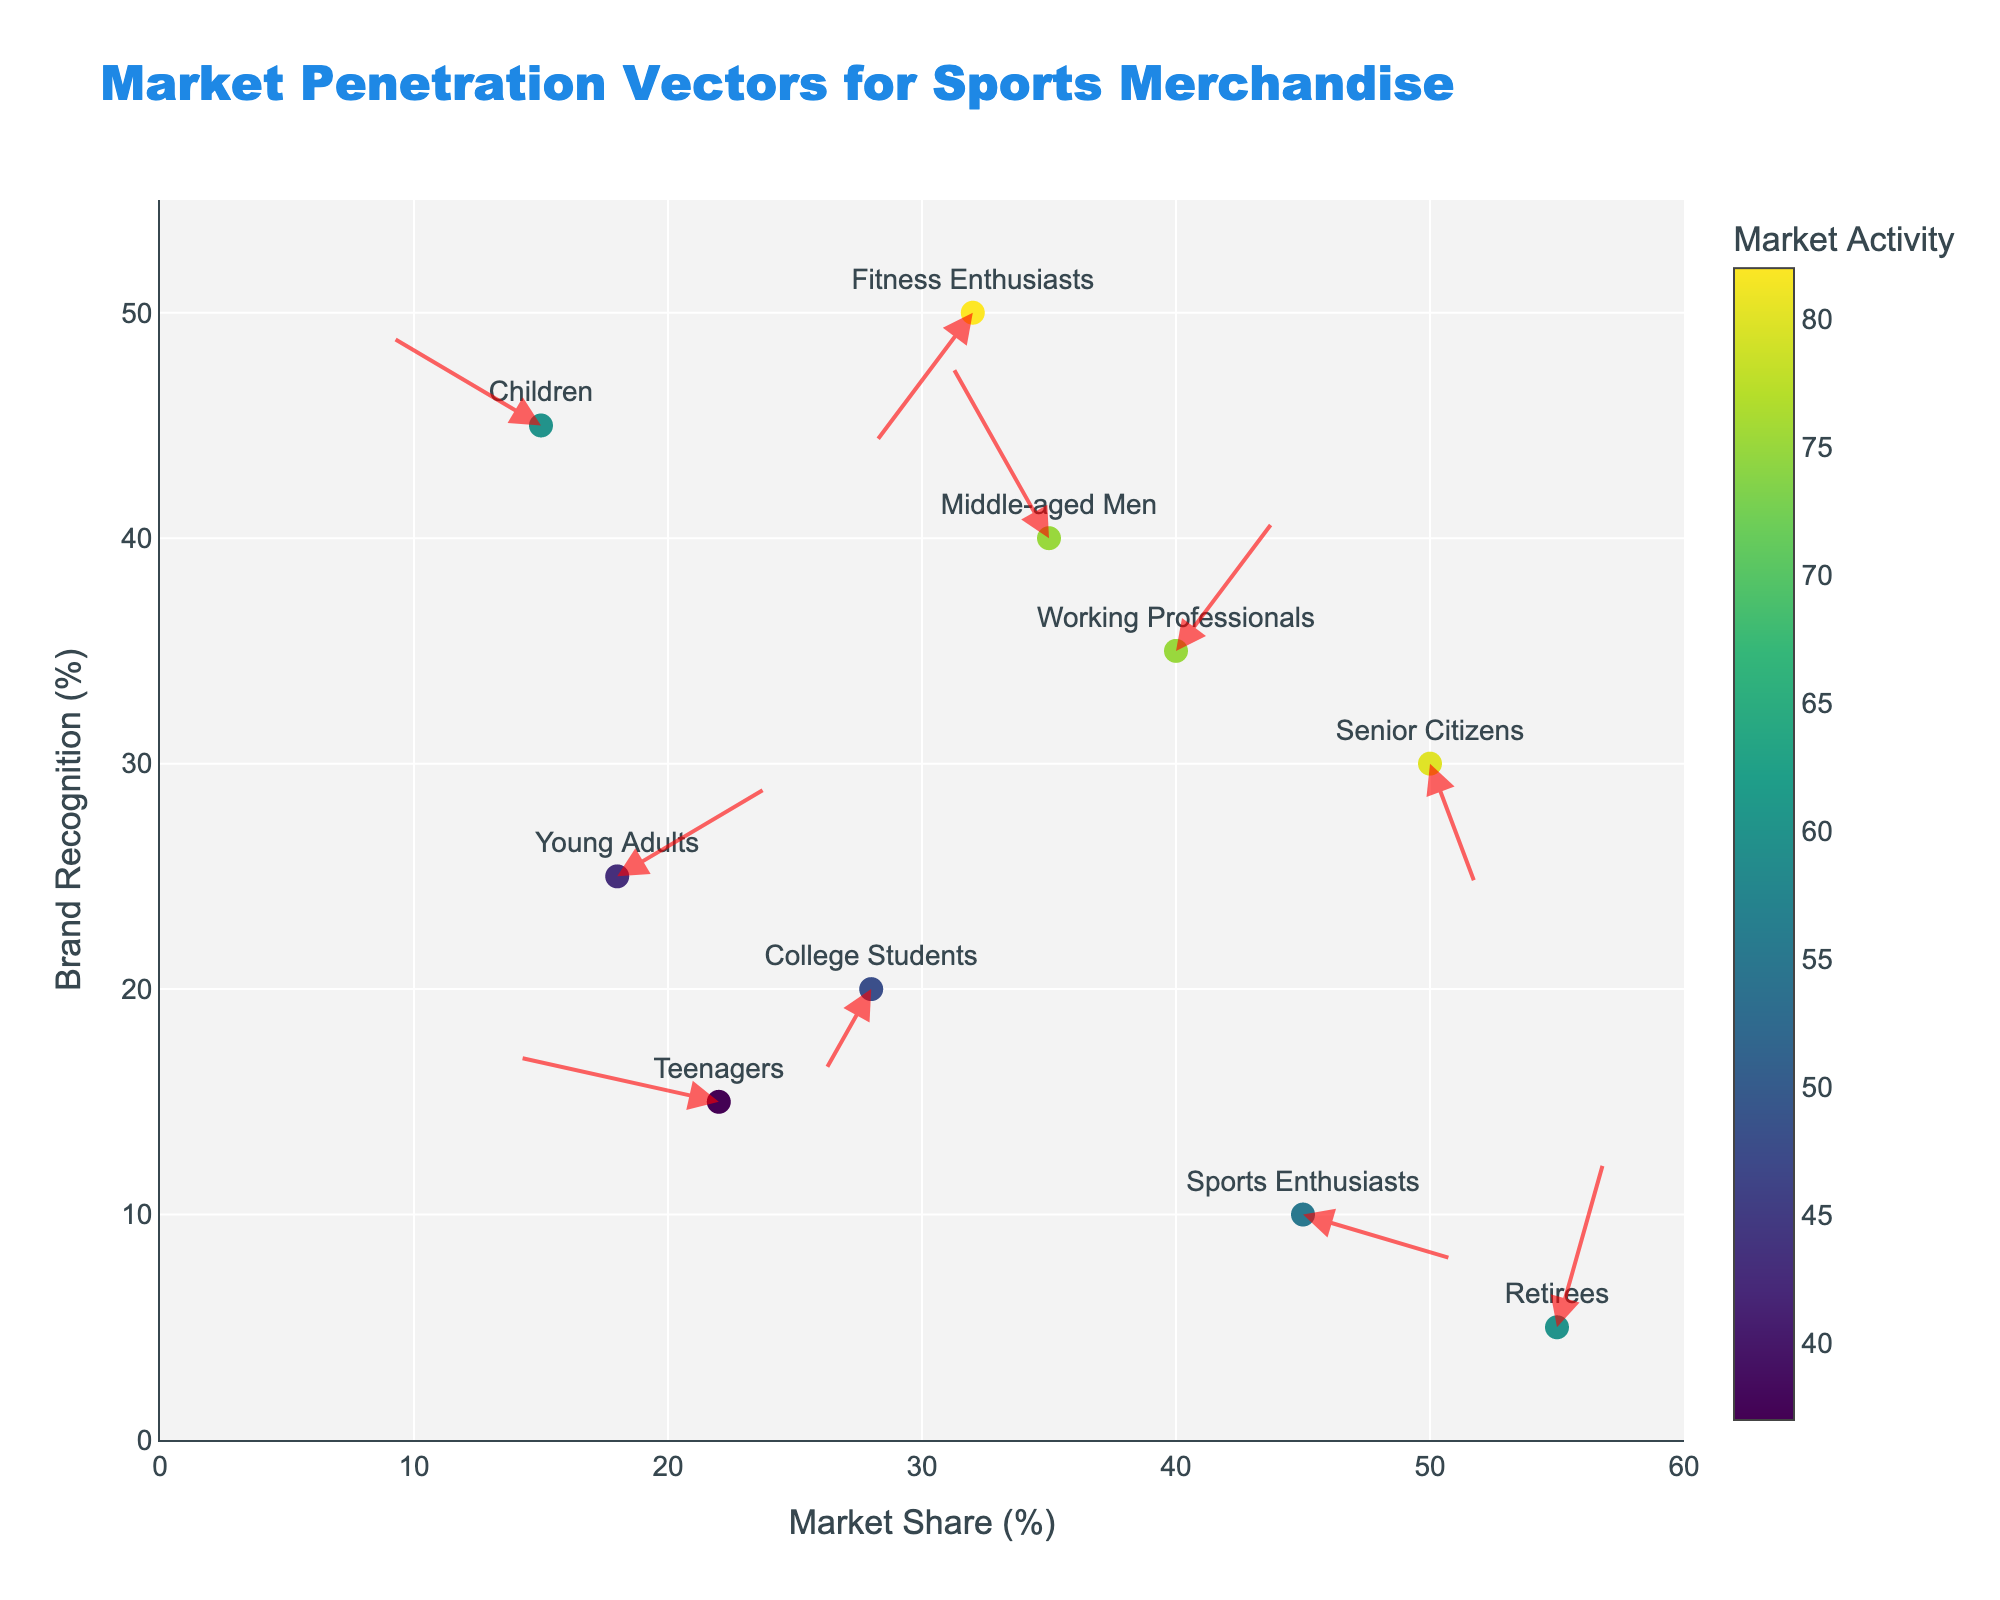How does the brand recognition for Sports Enthusiasts compare to Retirees? To determine brand recognition, look at the Y-axis value. Sports Enthusiasts have a Y value of 10, while Retirees have a Y value of 5. Thus, Sports Enthusiasts have a higher brand recognition than Retirees.
Answer: Sports Enthusiasts have higher brand recognition Which demographic segment shows the greatest increase in both market share and brand recognition? Look at the U and V vectors to determine the changes in market share and brand recognition. Working Professionals have U and V values of 2 and 3 respectively, indicating the largest increase in both metrics.
Answer: Working Professionals What demographic has the lowest market share? Check the X-axis values to find the lowest market share. Children, with an X value of 15, have the lowest market share.
Answer: Children Which brand is targeting Teenagers, and what is its market share? Find the demographic "Teenagers" and look at the associated brand. The market share is given by the X value. Teenagers are targeted by Puma with a market share of 22.
Answer: Puma, 22 Compare the brand recognition of College Students and Fitness Enthusiasts? Look at the Y values for both demographics. College Students have a Y value of 20, while Fitness Enthusiasts have a Y value of 50. Thus, Fitness Enthusiasts have higher brand recognition.
Answer: Fitness Enthusiasts What is the change in market share and brand recognition for Senior Citizens? Look at the U and V values for Senior Citizens. The U value is 1, implying a slight increase in market share, and the V value is -3, indicating a decrease in brand recognition.
Answer: +1 in market share, -3 in brand recognition Which demographic segment has a negative change in both market share and brand recognition? Check the U and V values for negative values. College Students have U value of -1 and V value of -2, indicating a negative change in both metrics.
Answer: College Students What brand is associated with the largest decrease in brand recognition? Look at the V values and identify the largest negative value. Adidas, targeting Senior Citizens, has V value of -3, the largest decrease in brand recognition.
Answer: Adidas How do the vectors for Young Adults compare to those for Working Professionals in terms of direction? The vectors for Young Adults (U=3, V=2) indicate an upward-right direction, while Working Professionals (U=2, V=3) also indicate an upward-right direction but with a slightly different emphasis on brand recognition increase.
Answer: Similar upward-right direction 